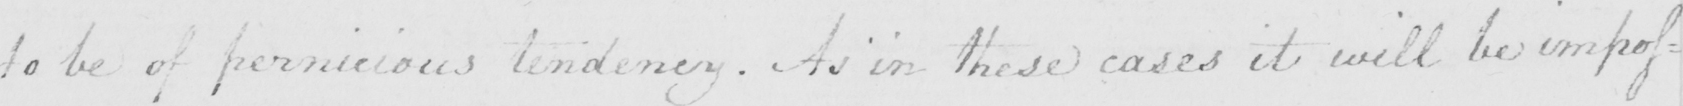Please provide the text content of this handwritten line. to be of pernicious tendency . As in these cases it will be impos= 